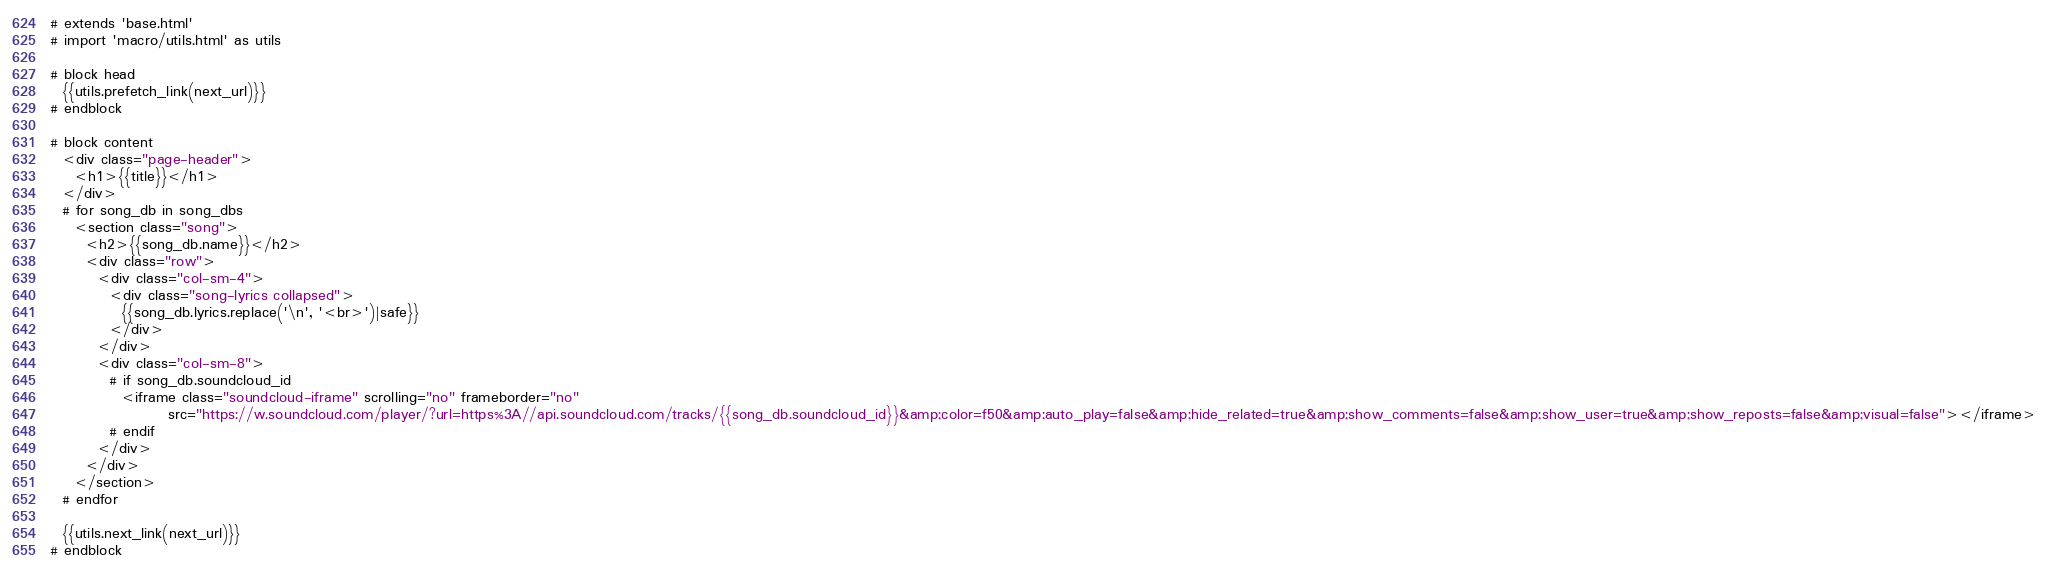Convert code to text. <code><loc_0><loc_0><loc_500><loc_500><_HTML_># extends 'base.html'
# import 'macro/utils.html' as utils

# block head
  {{utils.prefetch_link(next_url)}}
# endblock

# block content
  <div class="page-header">
    <h1>{{title}}</h1>
  </div>
  # for song_db in song_dbs
    <section class="song">
      <h2>{{song_db.name}}</h2>
      <div class="row">
        <div class="col-sm-4">
          <div class="song-lyrics collapsed">
            {{song_db.lyrics.replace('\n', '<br>')|safe}}
          </div>
        </div>
        <div class="col-sm-8">
          # if song_db.soundcloud_id
            <iframe class="soundcloud-iframe" scrolling="no" frameborder="no"
                    src="https://w.soundcloud.com/player/?url=https%3A//api.soundcloud.com/tracks/{{song_db.soundcloud_id}}&amp;color=f50&amp;auto_play=false&amp;hide_related=true&amp;show_comments=false&amp;show_user=true&amp;show_reposts=false&amp;visual=false"></iframe>
          # endif
        </div>
      </div>
    </section>
  # endfor

  {{utils.next_link(next_url)}}
# endblock
</code> 